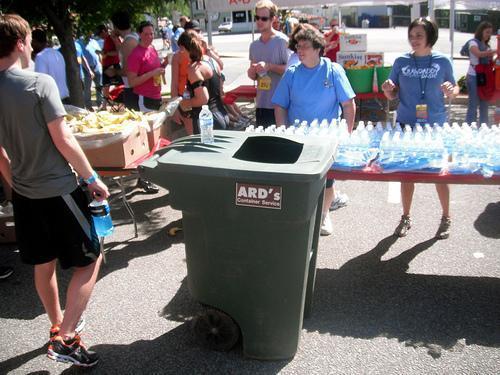How many people are in front of the tables?
Give a very brief answer. 1. 